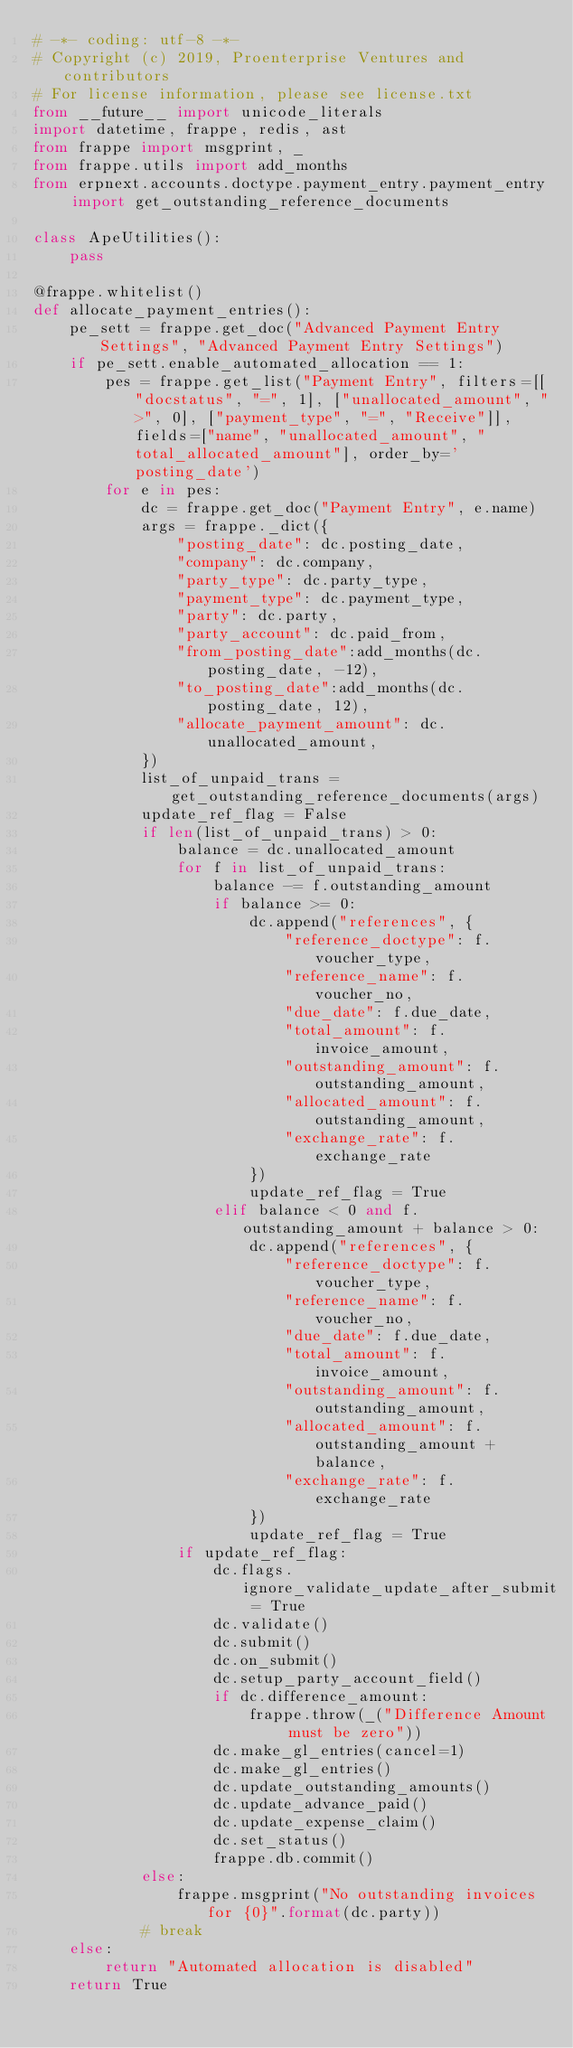Convert code to text. <code><loc_0><loc_0><loc_500><loc_500><_Python_># -*- coding: utf-8 -*-
# Copyright (c) 2019, Proenterprise Ventures and contributors
# For license information, please see license.txt
from __future__ import unicode_literals
import datetime, frappe, redis, ast
from frappe import msgprint, _
from frappe.utils import add_months
from erpnext.accounts.doctype.payment_entry.payment_entry import get_outstanding_reference_documents

class ApeUtilities():
    pass

@frappe.whitelist()
def allocate_payment_entries():
    pe_sett = frappe.get_doc("Advanced Payment Entry Settings", "Advanced Payment Entry Settings")
    if pe_sett.enable_automated_allocation == 1:
        pes = frappe.get_list("Payment Entry", filters=[["docstatus", "=", 1], ["unallocated_amount", ">", 0], ["payment_type", "=", "Receive"]], fields=["name", "unallocated_amount", "total_allocated_amount"], order_by='posting_date')
        for e in pes:
            dc = frappe.get_doc("Payment Entry", e.name)
            args = frappe._dict({
                "posting_date": dc.posting_date,
                "company": dc.company,
                "party_type": dc.party_type,
                "payment_type": dc.payment_type,
                "party": dc.party,
                "party_account": dc.paid_from,
                "from_posting_date":add_months(dc.posting_date, -12),
                "to_posting_date":add_months(dc.posting_date, 12),
                "allocate_payment_amount": dc.unallocated_amount,
            })
            list_of_unpaid_trans = get_outstanding_reference_documents(args)
            update_ref_flag = False
            if len(list_of_unpaid_trans) > 0:
                balance = dc.unallocated_amount
                for f in list_of_unpaid_trans:
                    balance -= f.outstanding_amount
                    if balance >= 0:
                        dc.append("references", {
                            "reference_doctype": f.voucher_type,
                            "reference_name": f.voucher_no,
                            "due_date": f.due_date,
                            "total_amount": f.invoice_amount,
                            "outstanding_amount": f.outstanding_amount,
                            "allocated_amount": f.outstanding_amount,
                            "exchange_rate": f.exchange_rate
                        })
                        update_ref_flag = True
                    elif balance < 0 and f.outstanding_amount + balance > 0:
                        dc.append("references", {
                            "reference_doctype": f.voucher_type,
                            "reference_name": f.voucher_no,
                            "due_date": f.due_date,
                            "total_amount": f.invoice_amount,
                            "outstanding_amount": f.outstanding_amount,
                            "allocated_amount": f.outstanding_amount + balance,
                            "exchange_rate": f.exchange_rate
                        })
                        update_ref_flag = True
                if update_ref_flag:
                    dc.flags.ignore_validate_update_after_submit = True
                    dc.validate()
                    dc.submit() 
                    dc.on_submit()
                    dc.setup_party_account_field()
                    if dc.difference_amount:
                        frappe.throw(_("Difference Amount must be zero"))
                    dc.make_gl_entries(cancel=1)
                    dc.make_gl_entries()
                    dc.update_outstanding_amounts()
                    dc.update_advance_paid()
                    dc.update_expense_claim()
                    dc.set_status()
                    frappe.db.commit()
            else:
                frappe.msgprint("No outstanding invoices for {0}".format(dc.party))
            # break
    else:
        return "Automated allocation is disabled"
    return True
</code> 